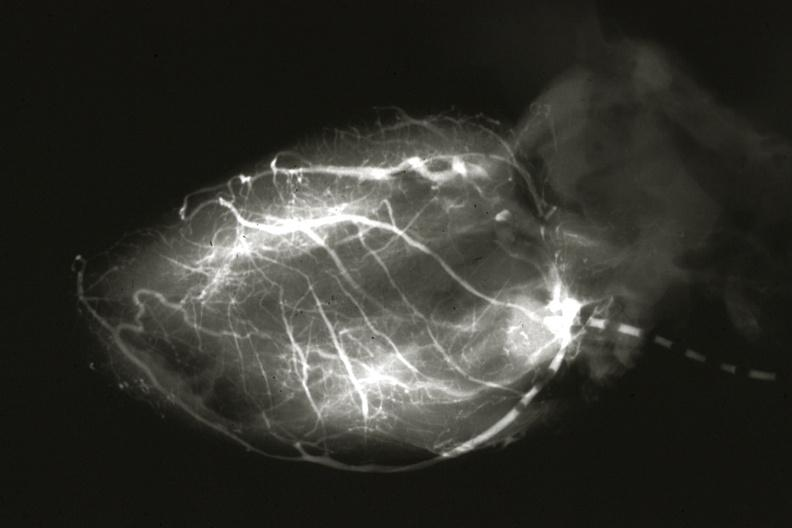how is anomalous origin left from artery?
Answer the question using a single word or phrase. Pulmonary 